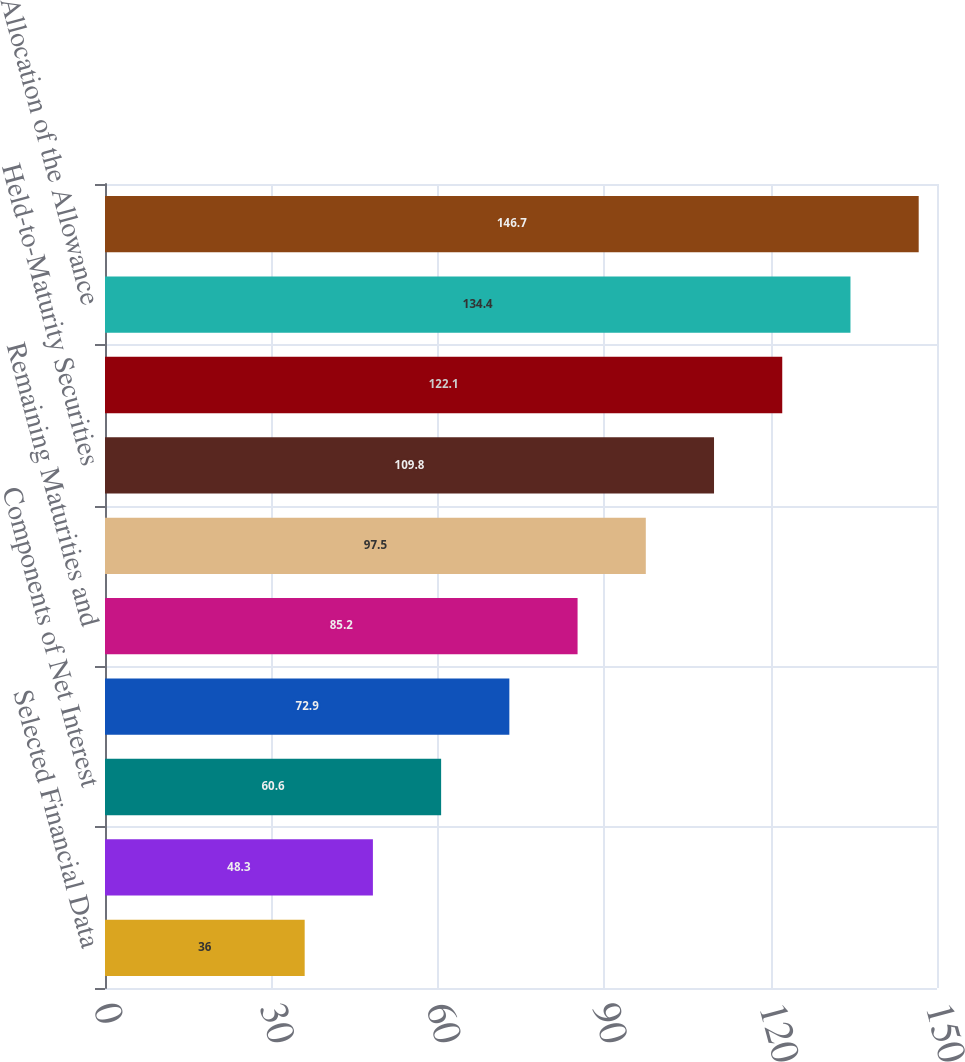<chart> <loc_0><loc_0><loc_500><loc_500><bar_chart><fcel>Selected Financial Data<fcel>Consolidated Average Balance<fcel>Components of Net Interest<fcel>Composition of Loans<fcel>Remaining Maturities and<fcel>Securities Available for Sale<fcel>Held-to-Maturity Securities<fcel>Maturity Distribution of Time<fcel>Allocation of the Allowance<fcel>Summary of Loan and Lease Loss<nl><fcel>36<fcel>48.3<fcel>60.6<fcel>72.9<fcel>85.2<fcel>97.5<fcel>109.8<fcel>122.1<fcel>134.4<fcel>146.7<nl></chart> 